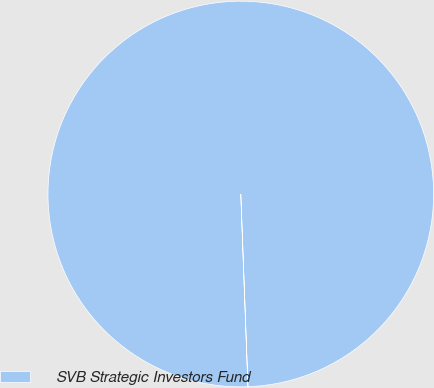Convert chart. <chart><loc_0><loc_0><loc_500><loc_500><pie_chart><fcel>SVB Strategic Investors Fund<nl><fcel>100.0%<nl></chart> 